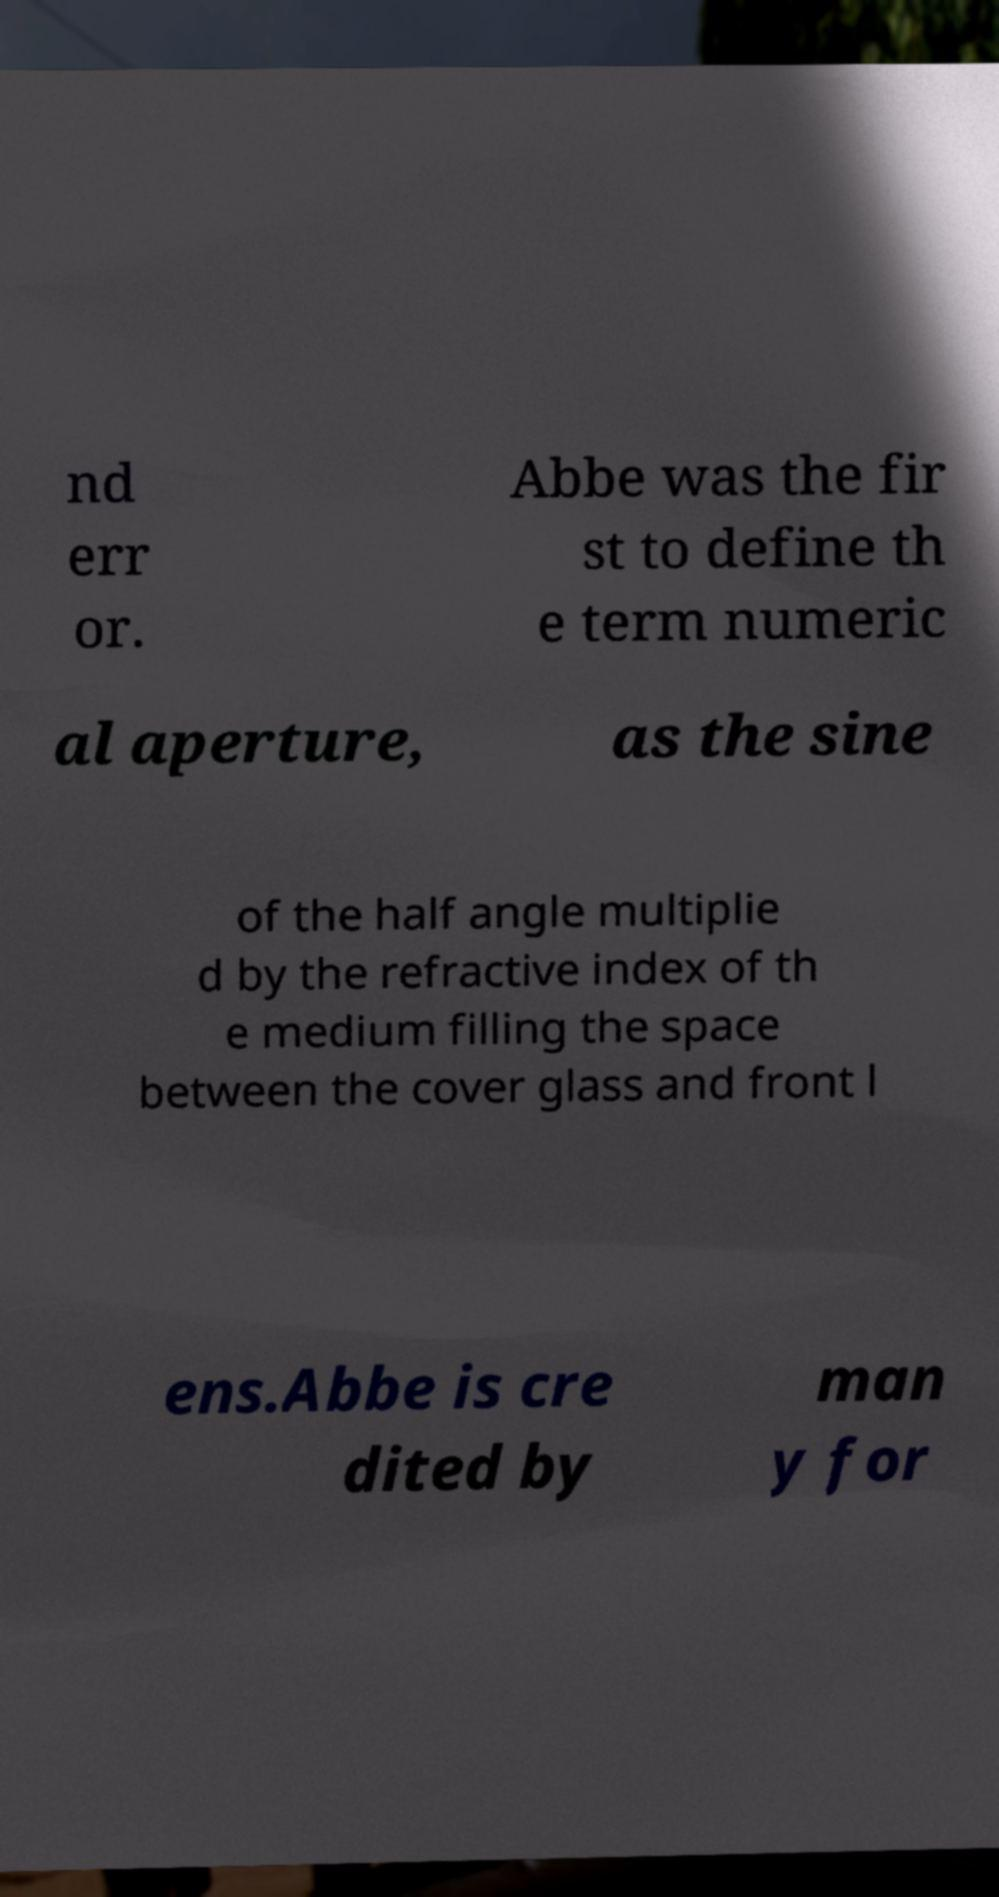Please identify and transcribe the text found in this image. nd err or. Abbe was the fir st to define th e term numeric al aperture, as the sine of the half angle multiplie d by the refractive index of th e medium filling the space between the cover glass and front l ens.Abbe is cre dited by man y for 